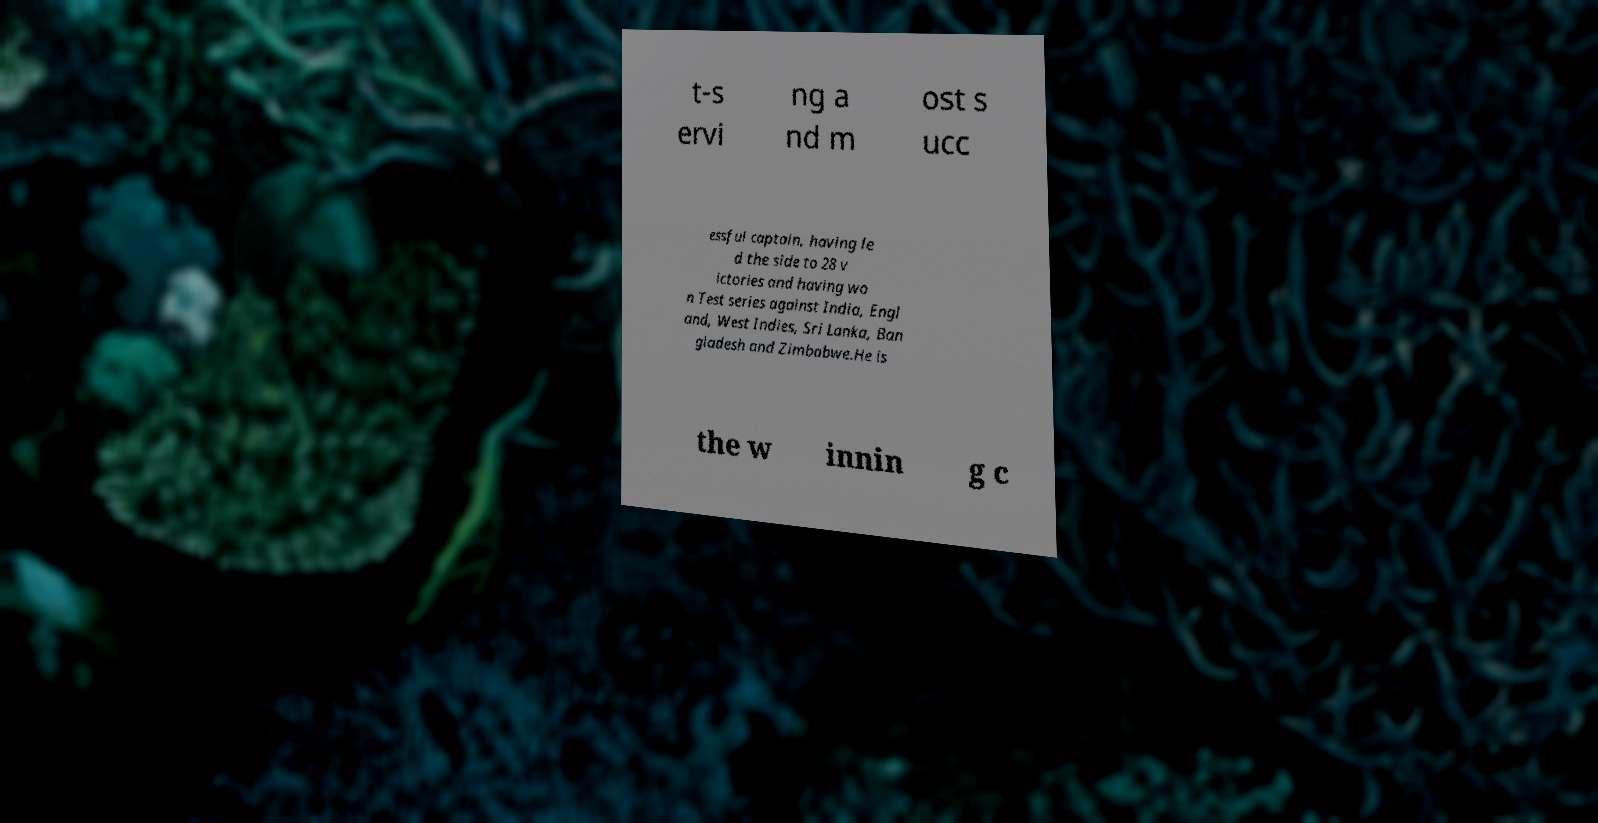Can you accurately transcribe the text from the provided image for me? t-s ervi ng a nd m ost s ucc essful captain, having le d the side to 28 v ictories and having wo n Test series against India, Engl and, West Indies, Sri Lanka, Ban gladesh and Zimbabwe.He is the w innin g c 